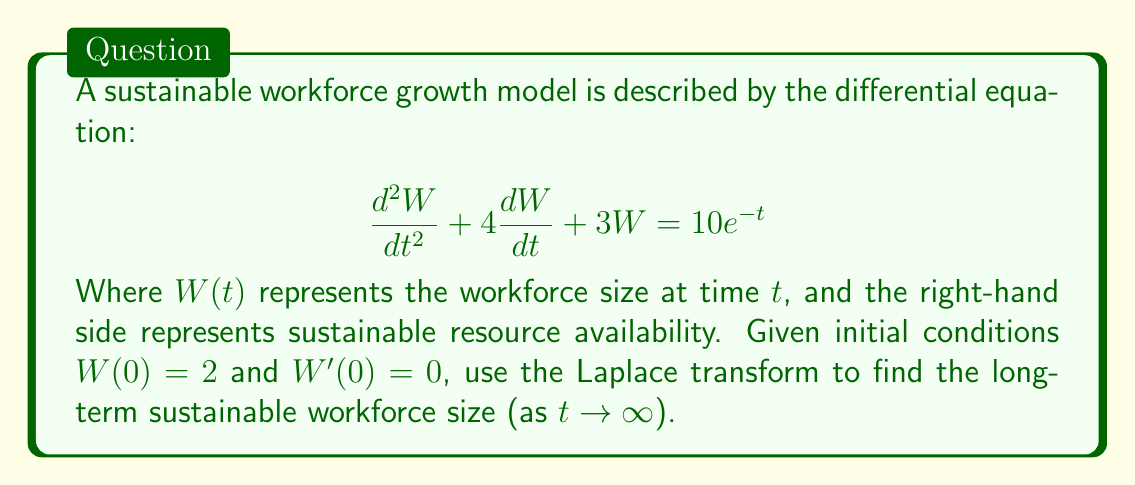Can you answer this question? To solve this problem using Laplace transforms, we'll follow these steps:

1) Take the Laplace transform of both sides of the equation:
   $$\mathcal{L}\{W''(t) + 4W'(t) + 3W(t)\} = \mathcal{L}\{10e^{-t}\}$$

2) Using Laplace transform properties:
   $$(s^2\mathcal{L}\{W(t)\} - sW(0) - W'(0)) + 4(s\mathcal{L}\{W(t)\} - W(0)) + 3\mathcal{L}\{W(t)\} = \frac{10}{s+1}$$

3) Substitute the initial conditions and let $\mathcal{L}\{W(t)\} = X(s)$:
   $$(s^2X(s) - 2s) + 4(sX(s) - 2) + 3X(s) = \frac{10}{s+1}$$

4) Simplify:
   $$s^2X(s) + 4sX(s) + 3X(s) - 2s - 8 = \frac{10}{s+1}$$
   $$(s^2 + 4s + 3)X(s) = \frac{10}{s+1} + 2s + 8$$

5) Solve for $X(s)$:
   $$X(s) = \frac{10}{(s+1)(s^2 + 4s + 3)} + \frac{2s + 8}{s^2 + 4s + 3}$$

6) Decompose into partial fractions:
   $$X(s) = \frac{A}{s+1} + \frac{B}{s+1} + \frac{Cs+D}{s^2 + 4s + 3}$$

   Where $A$, $B$, $C$, and $D$ are constants to be determined.

7) The long-term behavior is determined by the constant term in the time domain, which corresponds to the term $\frac{A}{s+1}$ in the s-domain.

8) Solving for $A$, we find $A = \frac{10}{3}$.

9) Therefore, as $t \to \infty$, $W(t) \to \frac{10}{3}$.
Answer: The long-term sustainable workforce size is $\frac{10}{3}$ or approximately 3.33 units. 